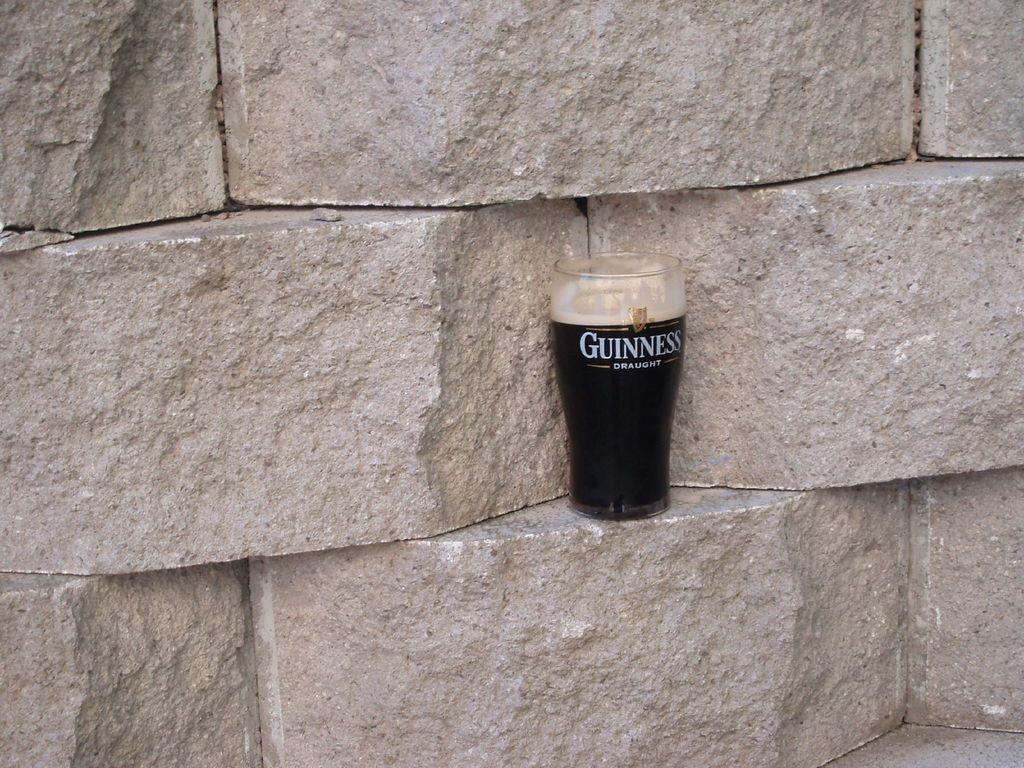Provide a one-sentence caption for the provided image. A glass of Guinness is sitting on a stone wall. 